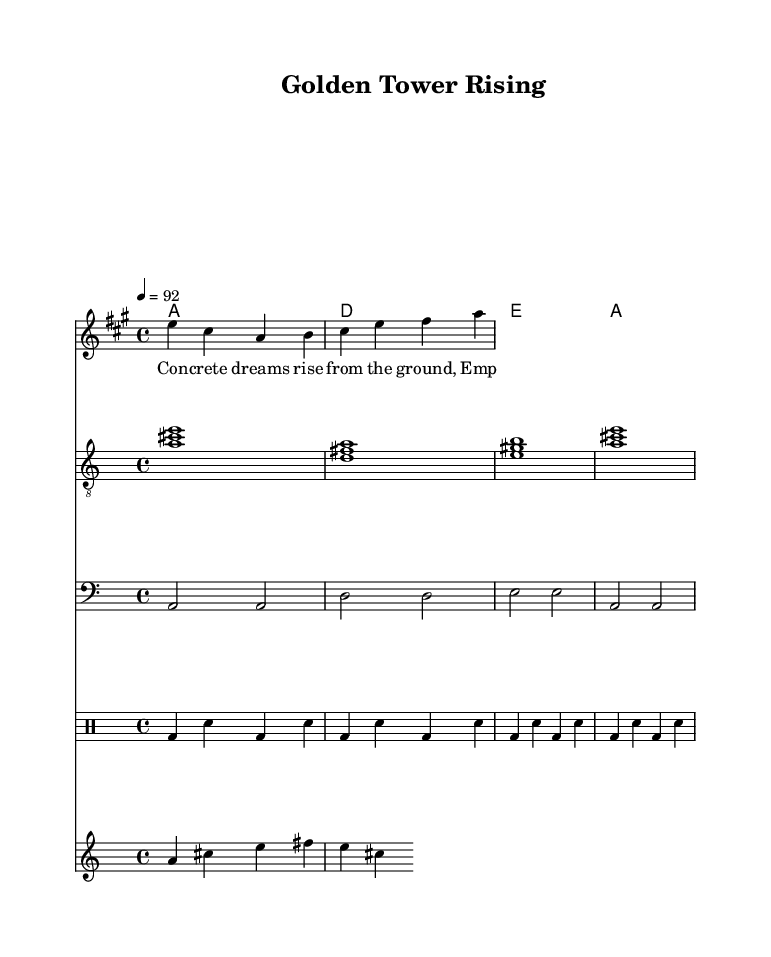What is the key signature of this music? The key signature is A major, which contains three sharps: F#, C#, and G#. This can be determined by looking at the key indicated in the global section of the sheet music.
Answer: A major What is the time signature of this music? The time signature is 4/4, as specified in the global section. This indicates there are four beats in a measure, and the quarter note gets one beat.
Answer: 4/4 What is the tempo marking for this piece? The tempo marking is 92, as indicated in the global section with a tempo of 4 = 92. This means there are 92 beats per minute.
Answer: 92 How many chords are used in the chord progression? There are four chords used in the chord progression: A, D, E, and A. This can be seen listed sequentially under the chordNames section.
Answer: Four What type of instruments are included in this arrangement? The arrangement includes guitar, bass, and horns, which can be identified under the different staff sections for the lead, guitar, bass, and horns.
Answer: Guitar, bass, horns What kind of rhythmic pattern does the drum staff follow? The drum staff follows a repeated pattern of bass drum and snare drum, specifically playing the bass drum on the first and third beats and the snare drum on the second and fourth beats. This pattern is indicated in the drummode section.
Answer: Repeated bass and snare What lyrical theme is depicted in the verse? The lyrical theme focuses on construction and financial success, with phrases indicating the transformation of empty spaces into valuable properties and dreams. This can be inferred from the lyrics provided in the verse section.
Answer: Construction, financial success 